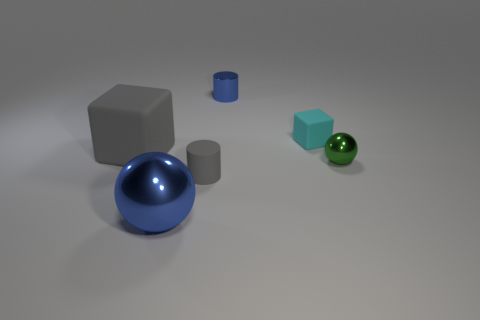Add 2 blue metal objects. How many objects exist? 8 Subtract all cylinders. How many objects are left? 4 Add 1 green metal things. How many green metal things exist? 2 Subtract 0 purple cylinders. How many objects are left? 6 Subtract all cyan matte balls. Subtract all big rubber things. How many objects are left? 5 Add 6 cylinders. How many cylinders are left? 8 